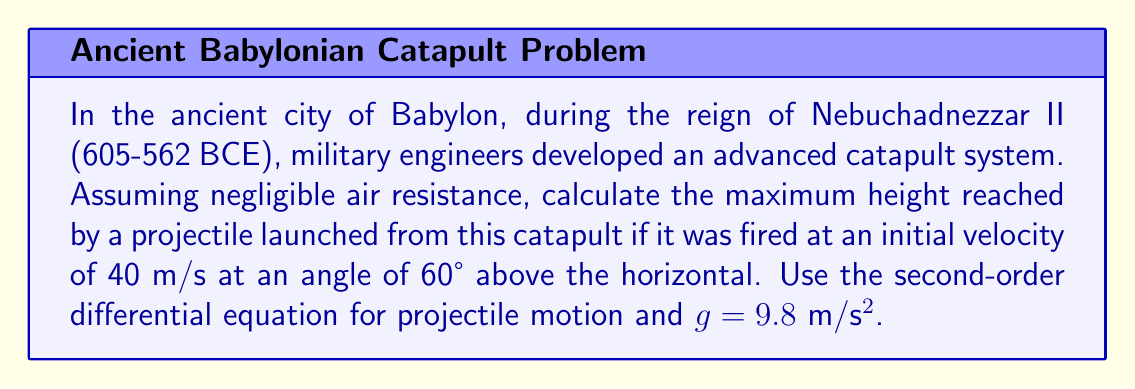What is the answer to this math problem? To solve this problem, we'll use the second-order differential equation for projectile motion. Let's break it down step by step:

1) The second-order differential equation for projectile motion in two dimensions is:

   $$\frac{d^2x}{dt^2} = 0$$
   $$\frac{d^2y}{dt^2} = -g$$

   Where g is the acceleration due to gravity (9.8 m/s²).

2) The initial conditions are:
   - Initial velocity: $v_0 = 40$ m/s
   - Launch angle: $\theta = 60°$
   - Initial position: $x_0 = 0$, $y_0 = 0$

3) We can break down the initial velocity into x and y components:
   $$v_{0x} = v_0 \cos(\theta) = 40 \cos(60°) = 20 \text{ m/s}$$
   $$v_{0y} = v_0 \sin(\theta) = 40 \sin(60°) = 34.64 \text{ m/s}$$

4) Integrating the differential equations with respect to time:
   $$\frac{dx}{dt} = v_{0x} = 20$$
   $$\frac{dy}{dt} = v_{0y} - gt = 34.64 - 9.8t$$

5) Integrating again:
   $$x = 20t$$
   $$y = 34.64t - 4.9t^2$$

6) The maximum height is reached when $\frac{dy}{dt} = 0$:
   $$34.64 - 9.8t = 0$$
   $$t = \frac{34.64}{9.8} = 3.53 \text{ seconds}$$

7) Substituting this time back into the equation for y:
   $$y_{max} = 34.64(3.53) - 4.9(3.53)^2$$
   $$y_{max} = 122.28 - 61.14 = 61.14 \text{ meters}$$

Therefore, the maximum height reached by the projectile is approximately 61.14 meters.
Answer: The maximum height reached by the projectile is approximately 61.14 meters. 